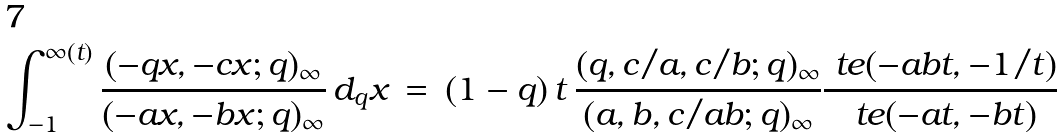Convert formula to latex. <formula><loc_0><loc_0><loc_500><loc_500>\int _ { - 1 } ^ { \infty ( t ) } \frac { ( - q x , - c x ; q ) _ { \infty } } { ( - a x , - b x ; q ) _ { \infty } } \, d _ { q } x \, = \, ( 1 - q ) \, t \, \frac { ( q , c / a , c / b ; q ) _ { \infty } } { ( a , b , c / a b ; q ) _ { \infty } } \frac { \ t e ( - a b t , - 1 / t ) } { \ t e ( - a t , - b t ) }</formula> 